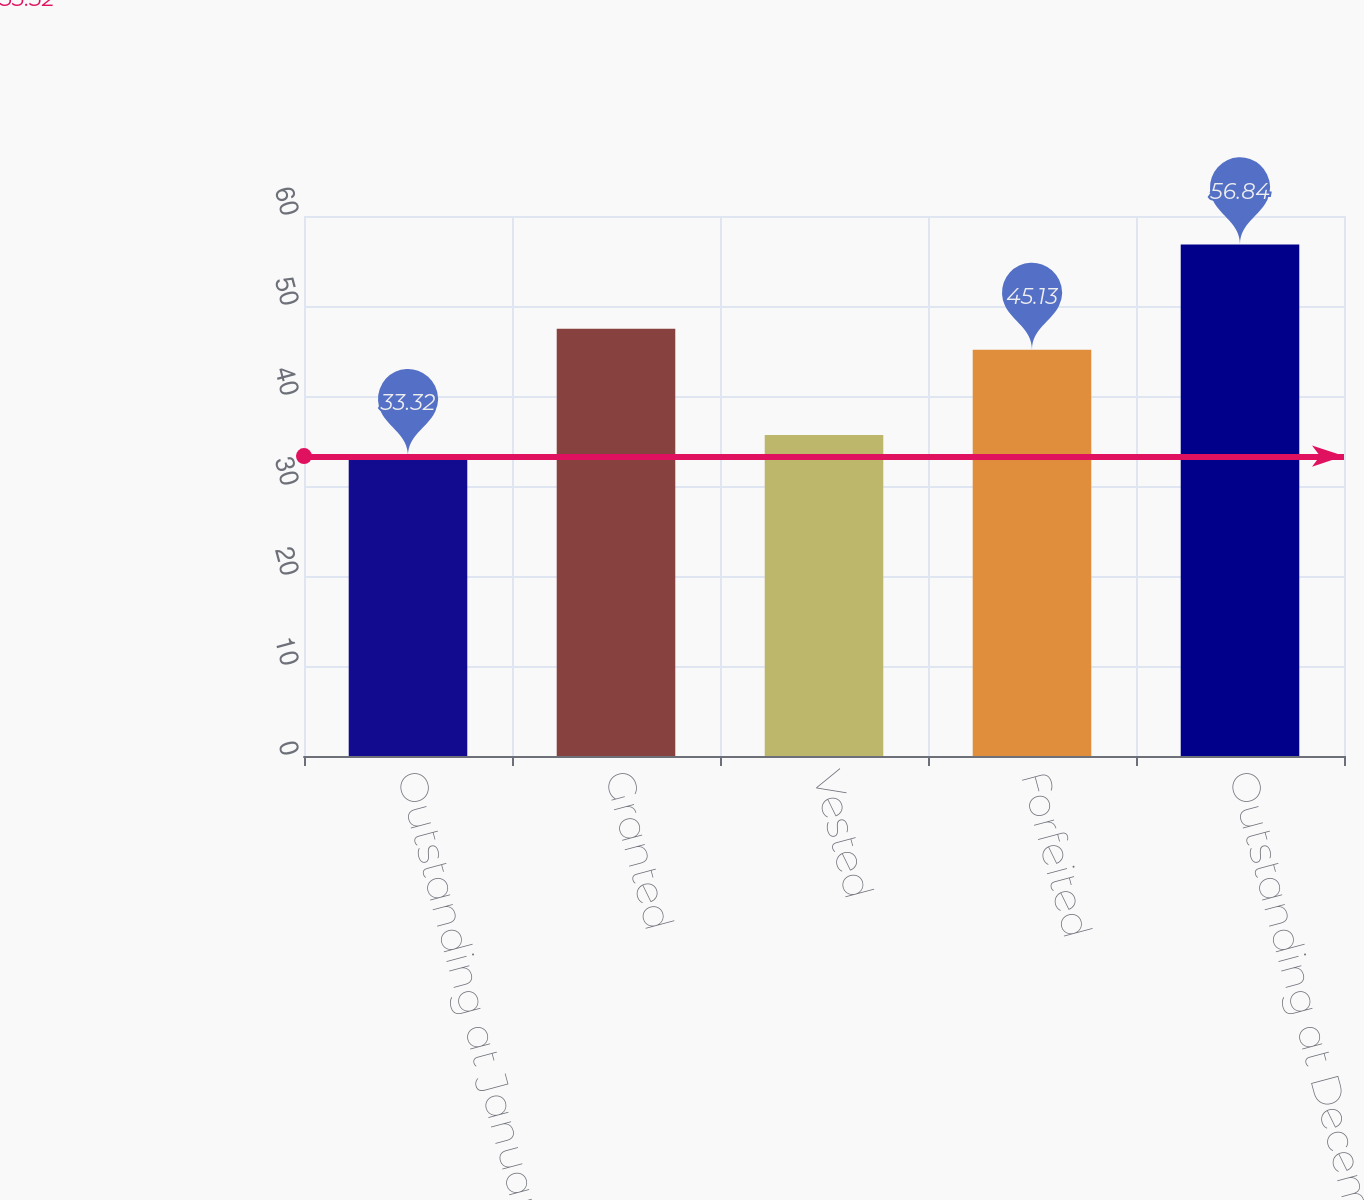Convert chart to OTSL. <chart><loc_0><loc_0><loc_500><loc_500><bar_chart><fcel>Outstanding at January 1 2012<fcel>Granted<fcel>Vested<fcel>Forfeited<fcel>Outstanding at December 31<nl><fcel>33.32<fcel>47.48<fcel>35.67<fcel>45.13<fcel>56.84<nl></chart> 